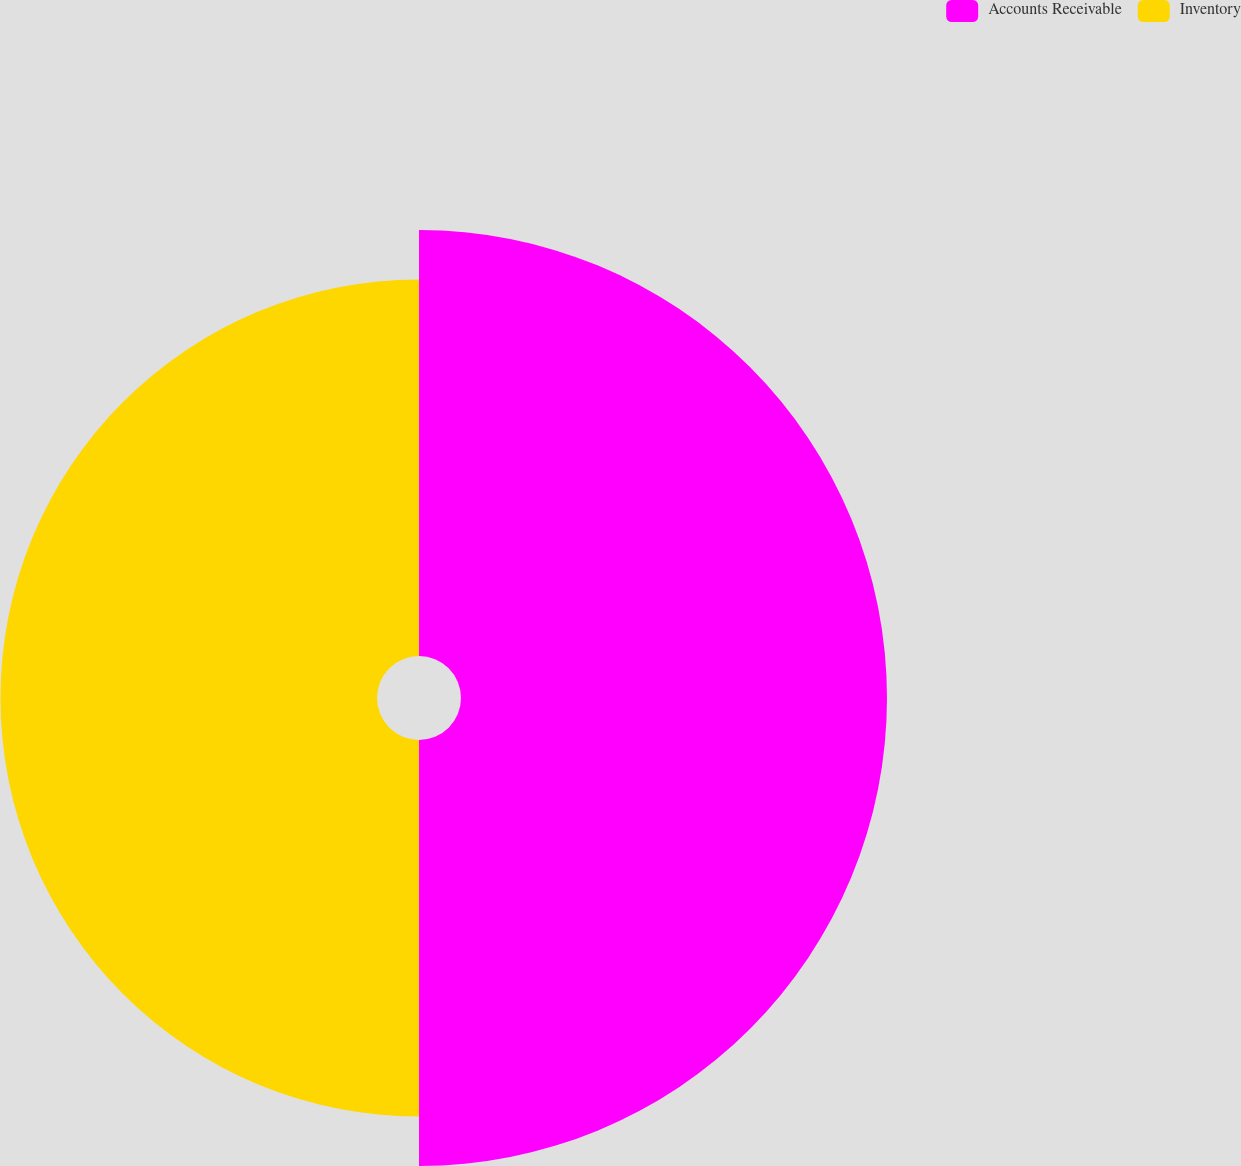Convert chart to OTSL. <chart><loc_0><loc_0><loc_500><loc_500><pie_chart><fcel>Accounts Receivable<fcel>Inventory<nl><fcel>53.08%<fcel>46.92%<nl></chart> 